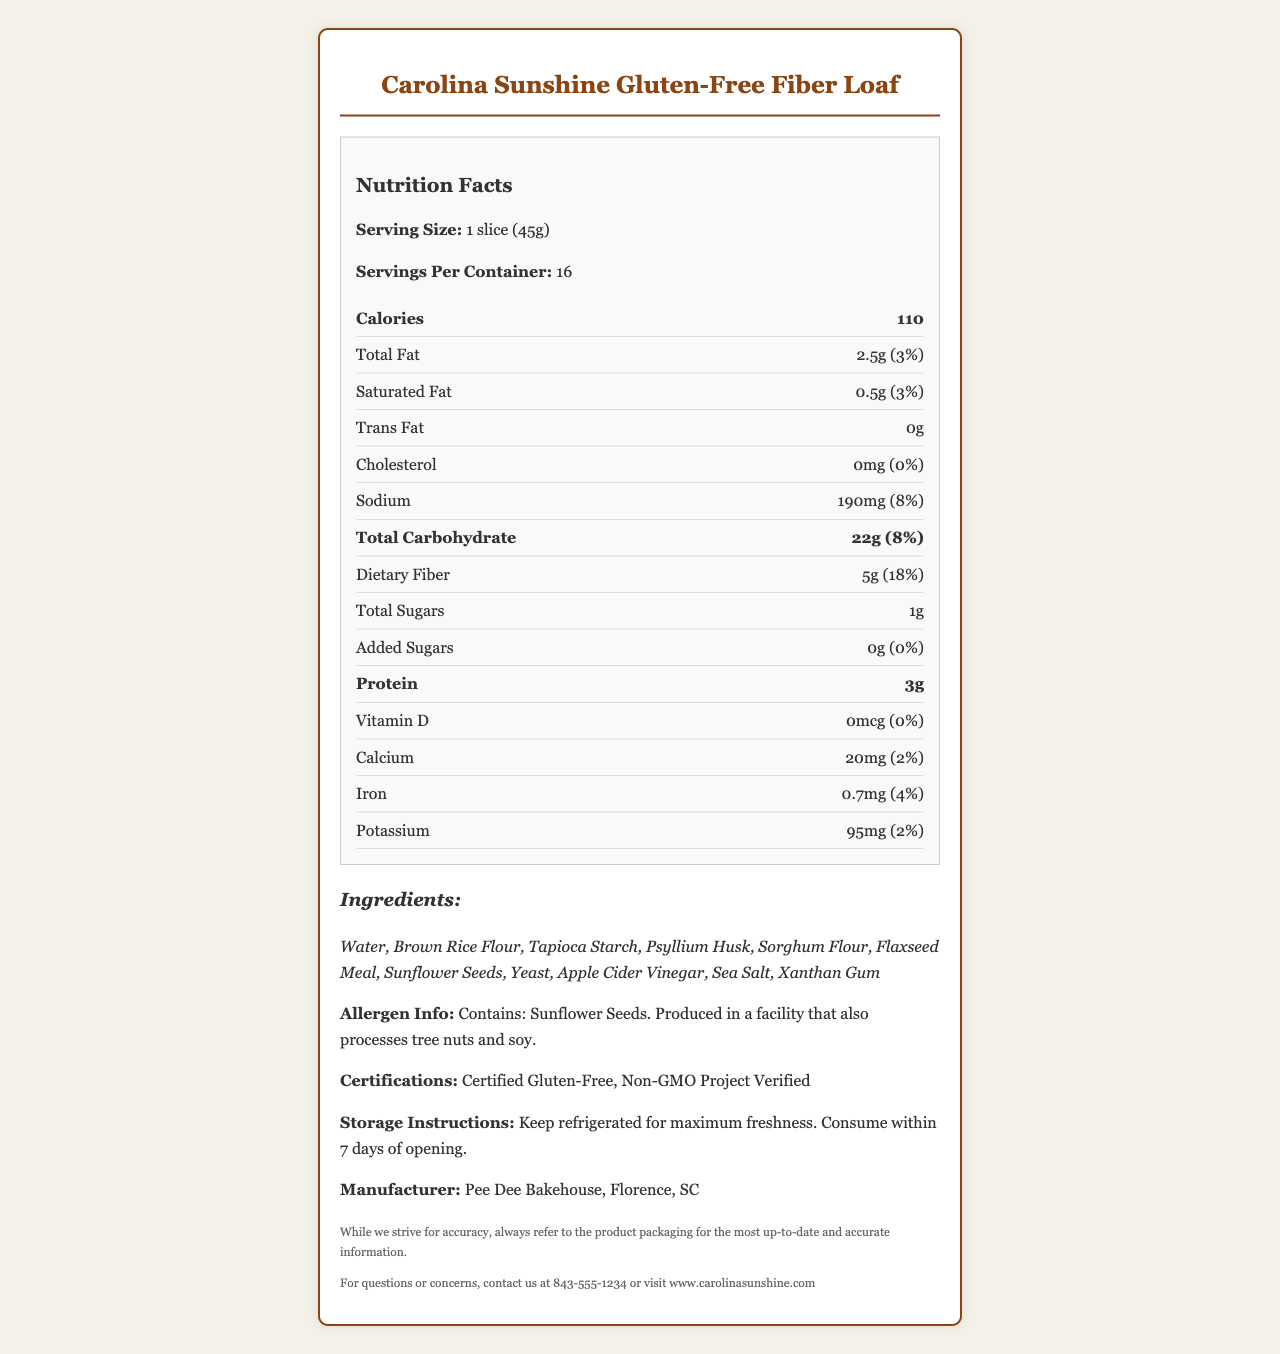what is the serving size for the Carolina Sunshine Gluten-Free Fiber Loaf? The document states that the serving size is "1 slice (45g)".
Answer: 1 slice (45g) how many servings are there per container? According to the document, there are 16 servings per container.
Answer: 16 what is the amount of dietary fiber per serving? The nutrition facts label indicates that each serving contains 5g of dietary fiber.
Answer: 5g what is the daily value percentage for total fat? The document shows that the daily value percentage for total fat is 3%.
Answer: 3% how much sodium does one slice contain? The sodium content per serving is listed as 190mg.
Answer: 190mg Which ingredient is listed first? The ingredients are listed in order by weight, and water is the first ingredient listed.
Answer: Water What certifications does the product have? A. USDA Organic B. Certified Gluten-Free C. Non-GMO Project Verified D. B & C E. All of the above The document lists "Certified Gluten-Free" and "Non-GMO Project Verified" as its certifications.
Answer: D. B & C How many grams of protein are in one serving? A. 2g B. 3g C. 4g D. 5g According to the nutrition facts, one serving contains 3g of protein.
Answer: B. 3g Is there any trans fat in the product? The document clearly states that there is 0g of trans fat in one serving.
Answer: No Does one serving of this product contain any cholesterol? The nutrition facts label indicates that there is 0mg of cholesterol in one serving.
Answer: No Summarize the main features of the Carolina Sunshine Gluten-Free Fiber Loaf. The document provides detailed nutritional information, a list of ingredients, allergen info, certifications, storage instructions, and the manufacturer’s information for the Carolina Sunshine Gluten-Free Fiber Loaf.
Answer: The Carolina Sunshine Gluten-Free Fiber Loaf is a gluten-free bread alternative with high fiber content, containing 5g of dietary fiber per serving. It is made with ingredients like brown rice flour and psyllium husk and is certified gluten-free and non-GMO. Each serving has 110 calories, 2.5g of total fat, and 3g of protein. The product should be refrigerated for freshness and consumed within 7 days of opening. How long should the product be consumed after opening? The storage instructions state that the product should be consumed within 7 days of opening.
Answer: Within 7 days Can this bread be used by someone with a tree nut allergy safely? The allergen info states that it is produced in a facility that processes tree nuts, so it's not certain if it is safe for someone with a tree nut allergy.
Answer: Not enough information 